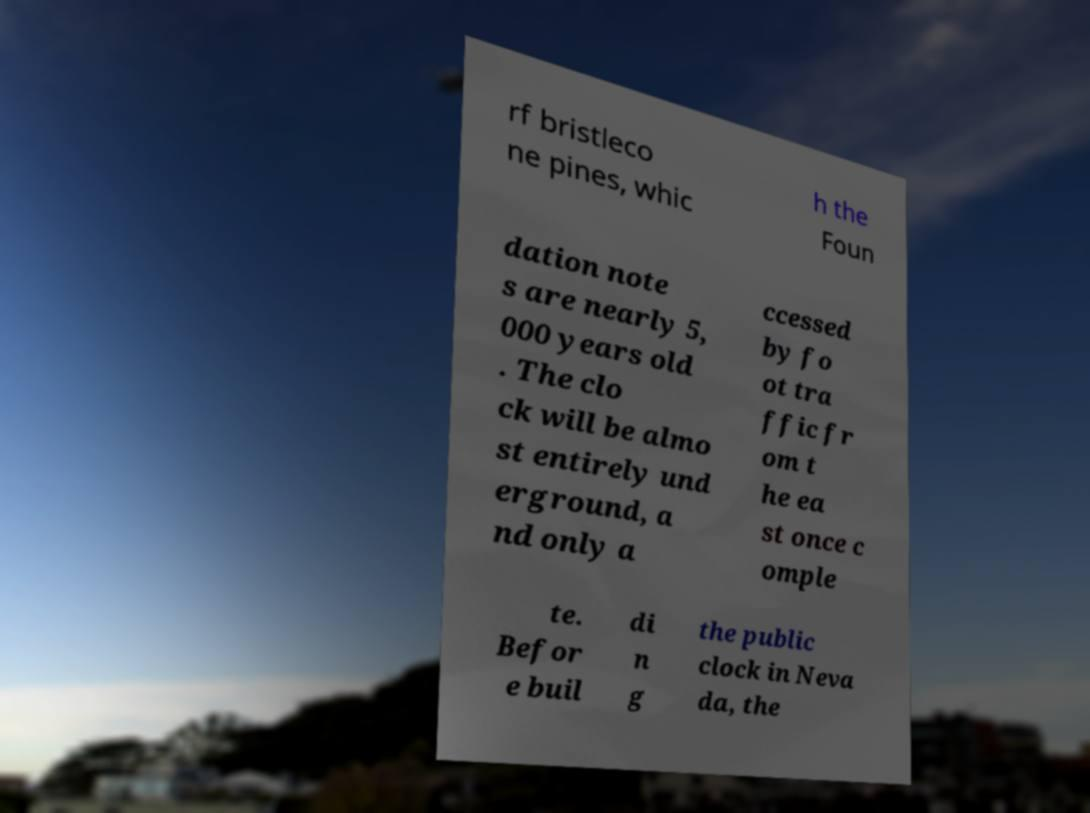For documentation purposes, I need the text within this image transcribed. Could you provide that? rf bristleco ne pines, whic h the Foun dation note s are nearly 5, 000 years old . The clo ck will be almo st entirely und erground, a nd only a ccessed by fo ot tra ffic fr om t he ea st once c omple te. Befor e buil di n g the public clock in Neva da, the 